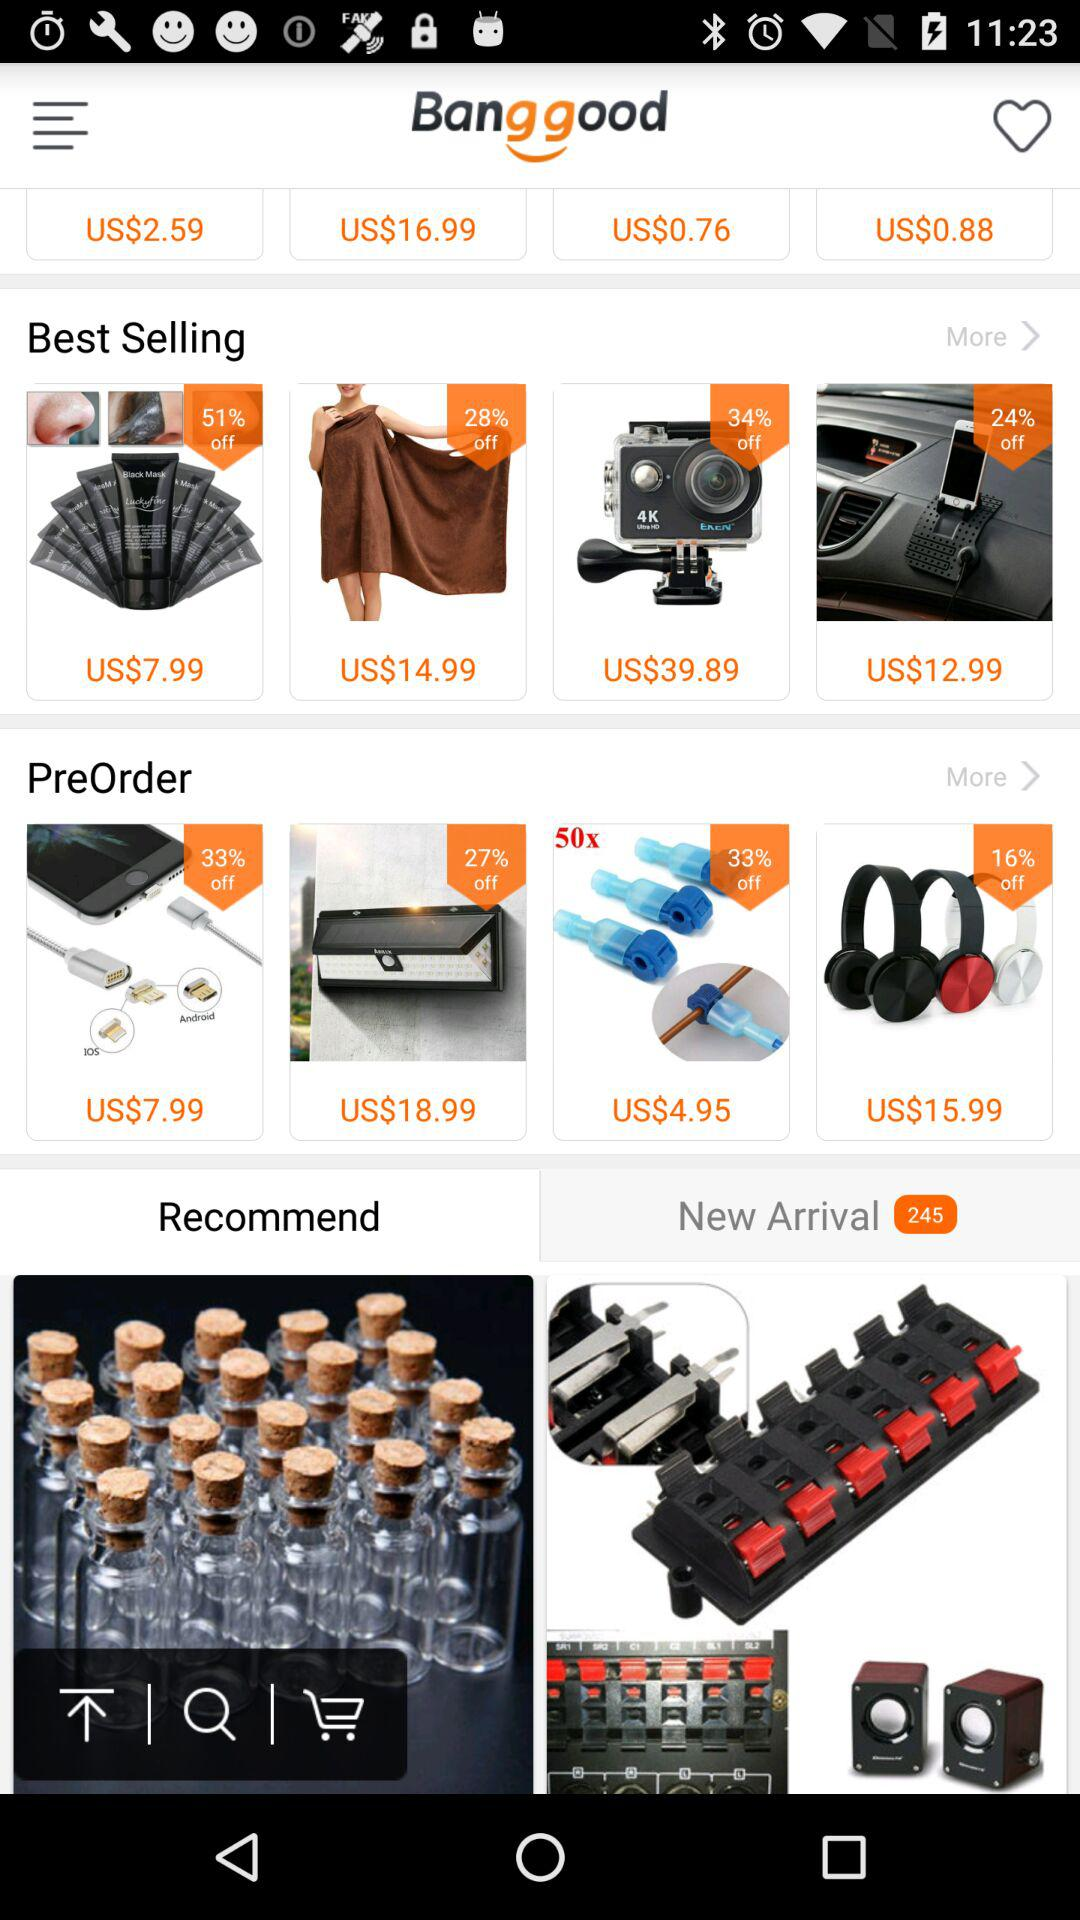What is the list of best selling?
When the provided information is insufficient, respond with <no answer>. <no answer> 